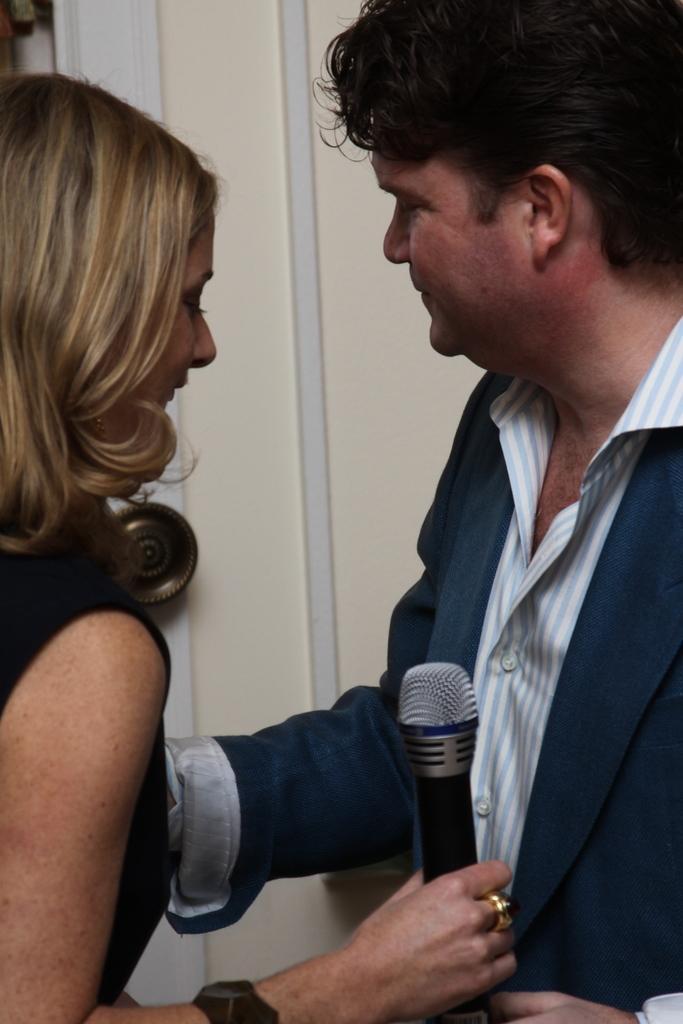Can you describe this image briefly? In this picture we can see a man and a women. She is holding a mike in her hand. 